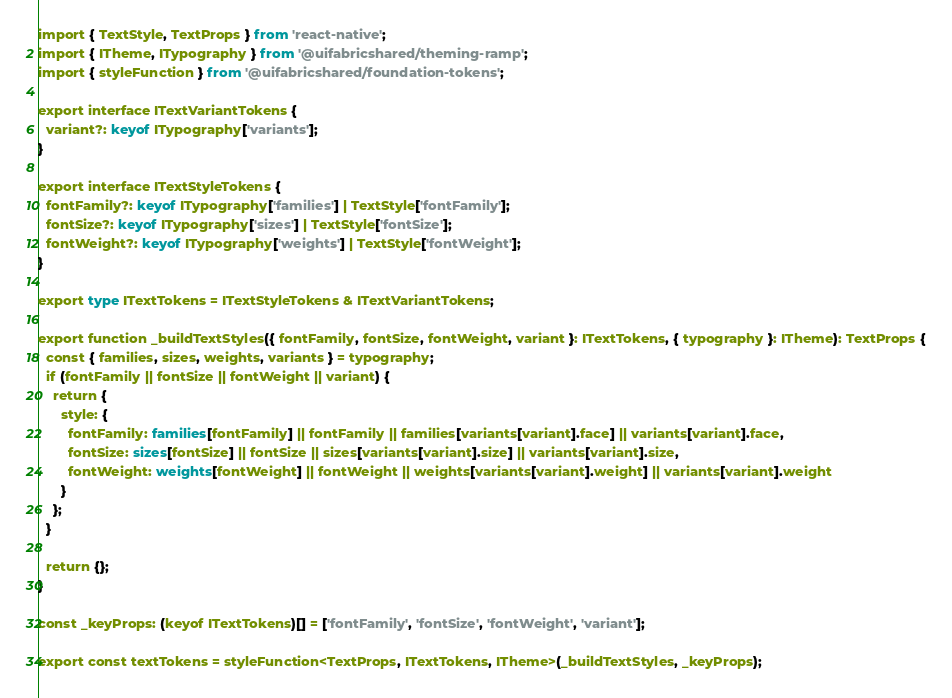<code> <loc_0><loc_0><loc_500><loc_500><_TypeScript_>import { TextStyle, TextProps } from 'react-native';
import { ITheme, ITypography } from '@uifabricshared/theming-ramp';
import { styleFunction } from '@uifabricshared/foundation-tokens';

export interface ITextVariantTokens {
  variant?: keyof ITypography['variants'];
}

export interface ITextStyleTokens {
  fontFamily?: keyof ITypography['families'] | TextStyle['fontFamily'];
  fontSize?: keyof ITypography['sizes'] | TextStyle['fontSize'];
  fontWeight?: keyof ITypography['weights'] | TextStyle['fontWeight'];
}

export type ITextTokens = ITextStyleTokens & ITextVariantTokens;

export function _buildTextStyles({ fontFamily, fontSize, fontWeight, variant }: ITextTokens, { typography }: ITheme): TextProps {
  const { families, sizes, weights, variants } = typography;
  if (fontFamily || fontSize || fontWeight || variant) {
    return {
      style: {
        fontFamily: families[fontFamily] || fontFamily || families[variants[variant].face] || variants[variant].face,
        fontSize: sizes[fontSize] || fontSize || sizes[variants[variant].size] || variants[variant].size,
        fontWeight: weights[fontWeight] || fontWeight || weights[variants[variant].weight] || variants[variant].weight
      }
    };
  }

  return {};
}

const _keyProps: (keyof ITextTokens)[] = ['fontFamily', 'fontSize', 'fontWeight', 'variant'];

export const textTokens = styleFunction<TextProps, ITextTokens, ITheme>(_buildTextStyles, _keyProps);
</code> 